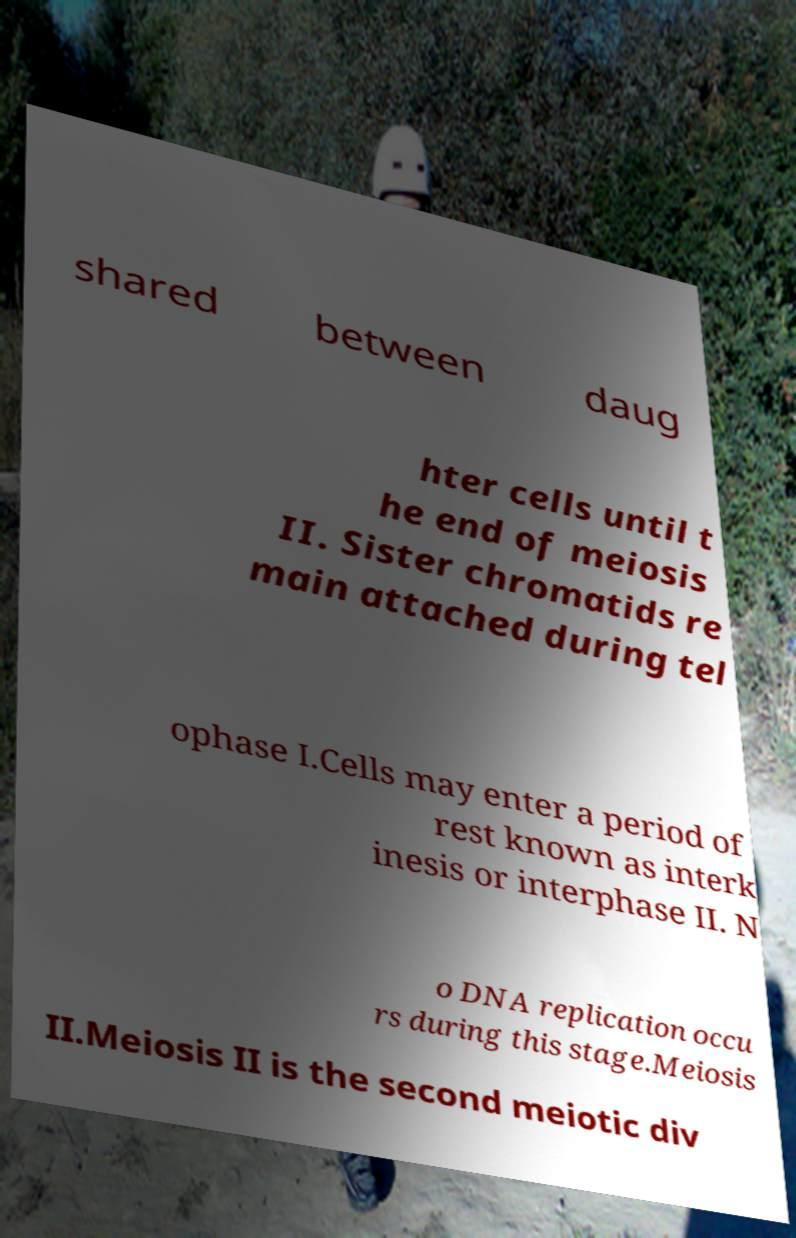For documentation purposes, I need the text within this image transcribed. Could you provide that? shared between daug hter cells until t he end of meiosis II. Sister chromatids re main attached during tel ophase I.Cells may enter a period of rest known as interk inesis or interphase II. N o DNA replication occu rs during this stage.Meiosis II.Meiosis II is the second meiotic div 